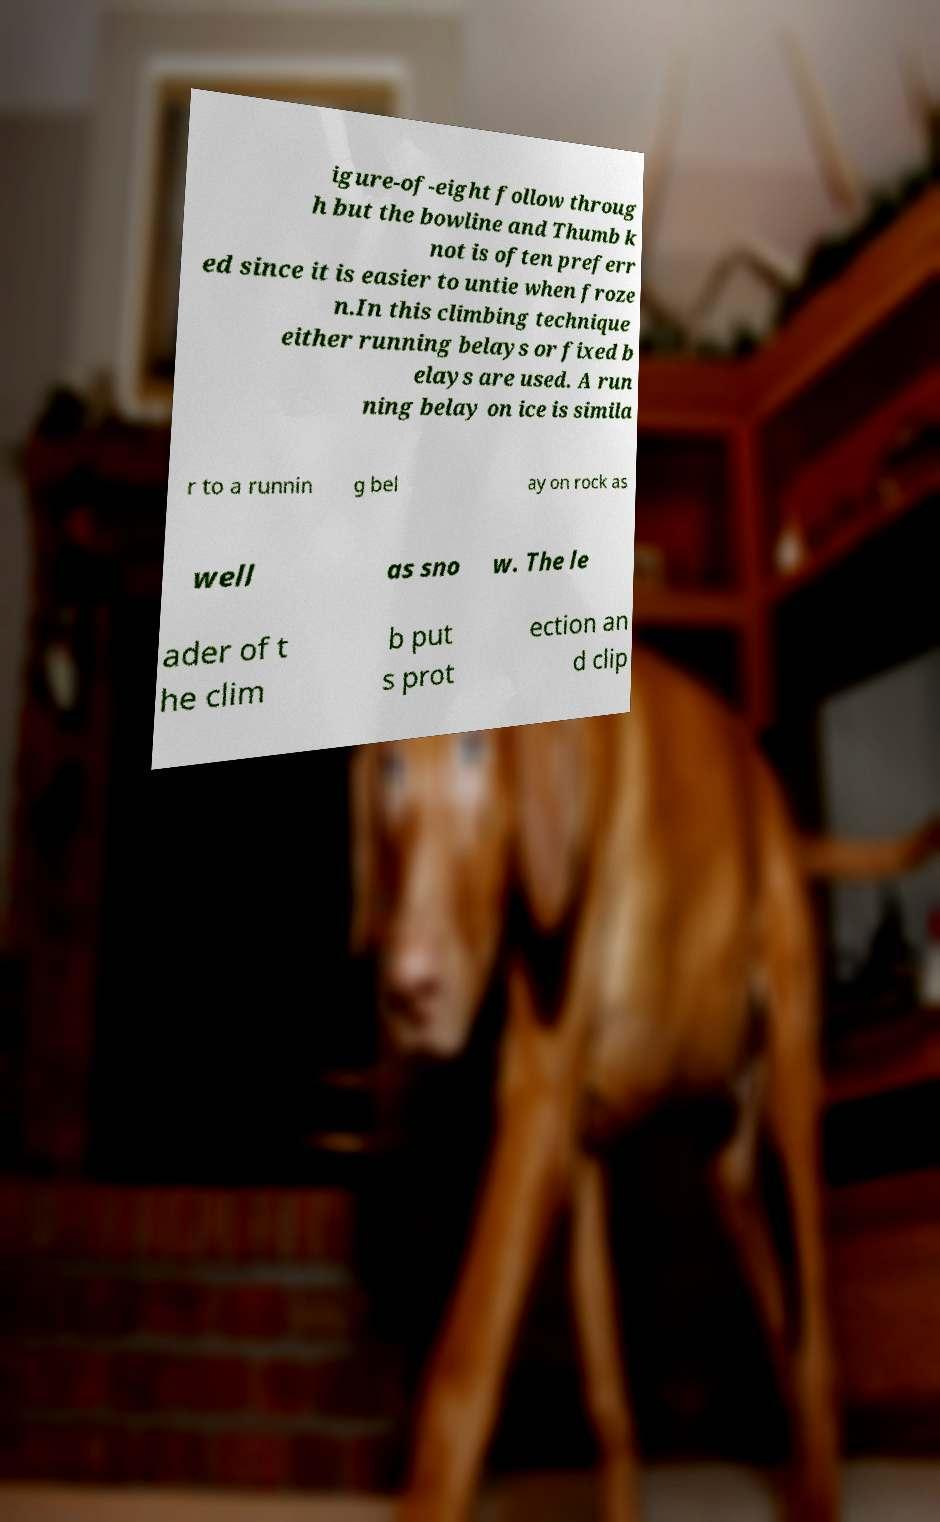Could you extract and type out the text from this image? igure-of-eight follow throug h but the bowline and Thumb k not is often preferr ed since it is easier to untie when froze n.In this climbing technique either running belays or fixed b elays are used. A run ning belay on ice is simila r to a runnin g bel ay on rock as well as sno w. The le ader of t he clim b put s prot ection an d clip 